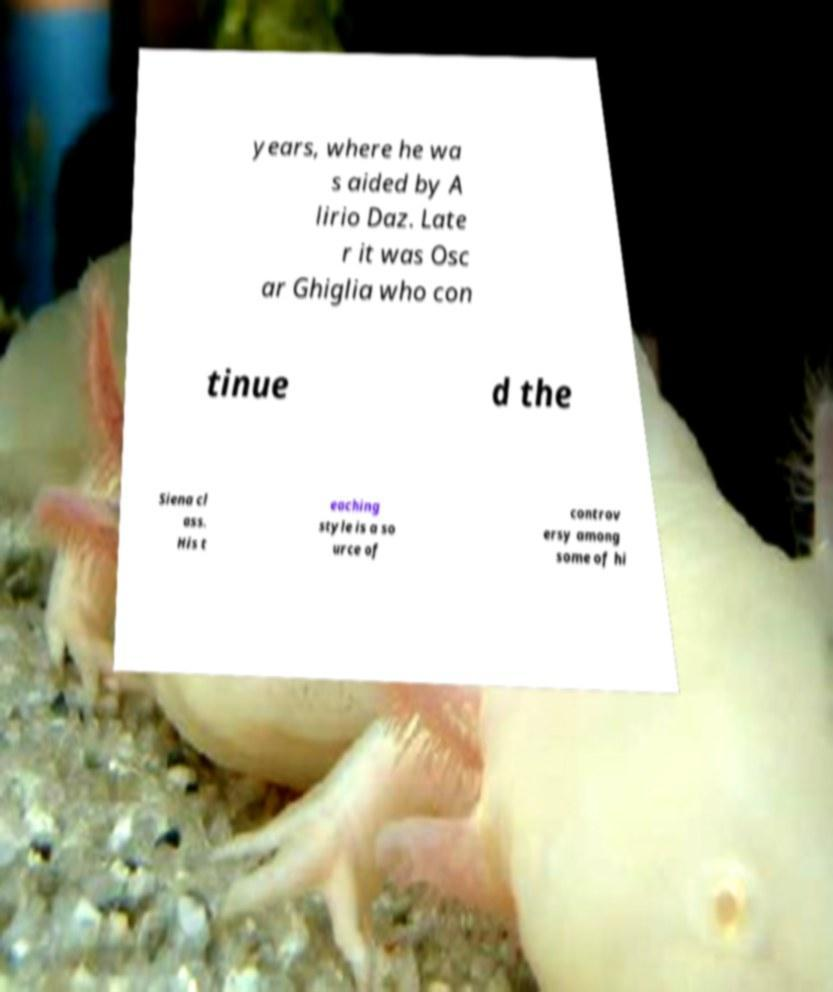Can you accurately transcribe the text from the provided image for me? years, where he wa s aided by A lirio Daz. Late r it was Osc ar Ghiglia who con tinue d the Siena cl ass. His t eaching style is a so urce of controv ersy among some of hi 